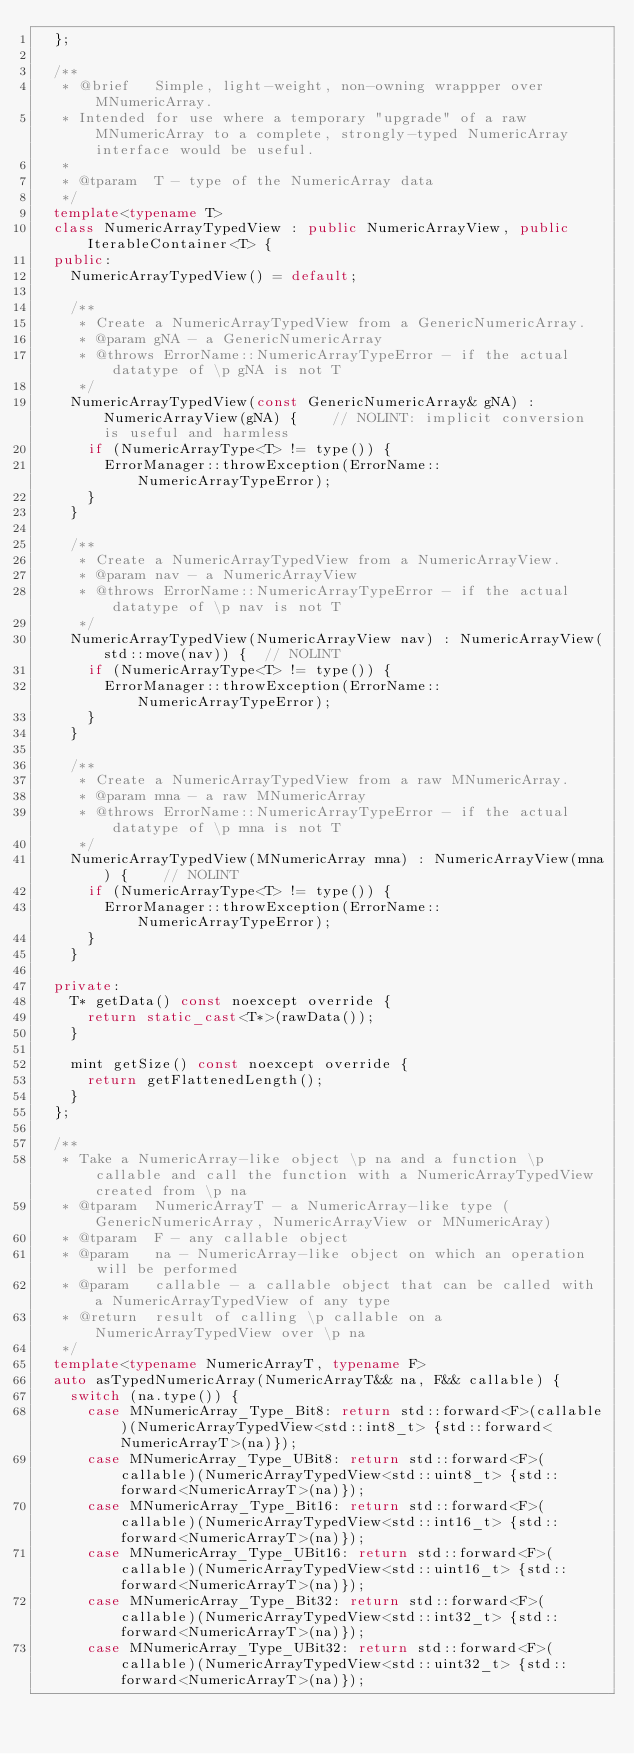Convert code to text. <code><loc_0><loc_0><loc_500><loc_500><_C++_>	};

	/**
	 * @brief   Simple, light-weight, non-owning wrappper over MNumericArray.
	 * Intended for use where a temporary "upgrade" of a raw MNumericArray to a complete, strongly-typed NumericArray interface would be useful.
	 *
	 * @tparam  T - type of the NumericArray data
	 */
	template<typename T>
	class NumericArrayTypedView : public NumericArrayView, public IterableContainer<T> {
	public:
		NumericArrayTypedView() = default;

		/**
		 * Create a NumericArrayTypedView from a GenericNumericArray.
		 * @param gNA - a GenericNumericArray
		 * @throws ErrorName::NumericArrayTypeError - if the actual datatype of \p gNA is not T
		 */
		NumericArrayTypedView(const GenericNumericArray& gNA) : NumericArrayView(gNA) {	   // NOLINT: implicit conversion is useful and harmless
			if (NumericArrayType<T> != type()) {
				ErrorManager::throwException(ErrorName::NumericArrayTypeError);
			}
		}

		/**
		 * Create a NumericArrayTypedView from a NumericArrayView.
		 * @param nav - a NumericArrayView
		 * @throws ErrorName::NumericArrayTypeError - if the actual datatype of \p nav is not T
		 */
		NumericArrayTypedView(NumericArrayView nav) : NumericArrayView(std::move(nav)) {	// NOLINT
			if (NumericArrayType<T> != type()) {
				ErrorManager::throwException(ErrorName::NumericArrayTypeError);
			}
		}

		/**
		 * Create a NumericArrayTypedView from a raw MNumericArray.
		 * @param mna - a raw MNumericArray
		 * @throws ErrorName::NumericArrayTypeError - if the actual datatype of \p mna is not T
		 */
		NumericArrayTypedView(MNumericArray mna) : NumericArrayView(mna) {	  // NOLINT
			if (NumericArrayType<T> != type()) {
				ErrorManager::throwException(ErrorName::NumericArrayTypeError);
			}
		}

	private:
		T* getData() const noexcept override {
			return static_cast<T*>(rawData());
		}

		mint getSize() const noexcept override {
			return getFlattenedLength();
		}
	};

	/**
	 * Take a NumericArray-like object \p na and a function \p callable and call the function with a NumericArrayTypedView created from \p na
	 * @tparam  NumericArrayT - a NumericArray-like type (GenericNumericArray, NumericArrayView or MNumericAray)
	 * @tparam  F - any callable object
	 * @param   na - NumericArray-like object on which an operation will be performed
	 * @param   callable - a callable object that can be called with a NumericArrayTypedView of any type
	 * @return  result of calling \p callable on a NumericArrayTypedView over \p na
	 */
	template<typename NumericArrayT, typename F>
	auto asTypedNumericArray(NumericArrayT&& na, F&& callable) {
		switch (na.type()) {
			case MNumericArray_Type_Bit8: return std::forward<F>(callable)(NumericArrayTypedView<std::int8_t> {std::forward<NumericArrayT>(na)});
			case MNumericArray_Type_UBit8: return std::forward<F>(callable)(NumericArrayTypedView<std::uint8_t> {std::forward<NumericArrayT>(na)});
			case MNumericArray_Type_Bit16: return std::forward<F>(callable)(NumericArrayTypedView<std::int16_t> {std::forward<NumericArrayT>(na)});
			case MNumericArray_Type_UBit16: return std::forward<F>(callable)(NumericArrayTypedView<std::uint16_t> {std::forward<NumericArrayT>(na)});
			case MNumericArray_Type_Bit32: return std::forward<F>(callable)(NumericArrayTypedView<std::int32_t> {std::forward<NumericArrayT>(na)});
			case MNumericArray_Type_UBit32: return std::forward<F>(callable)(NumericArrayTypedView<std::uint32_t> {std::forward<NumericArrayT>(na)});</code> 